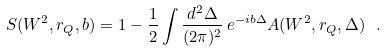<formula> <loc_0><loc_0><loc_500><loc_500>S ( W ^ { 2 } , r _ { Q } , b ) = 1 - \frac { 1 } { 2 } \int \frac { d ^ { 2 } \Delta } { ( 2 \pi ) ^ { 2 } } \, e ^ { - i { b } \Delta } A ( W ^ { 2 } , r _ { Q } , \Delta ) \ .</formula> 